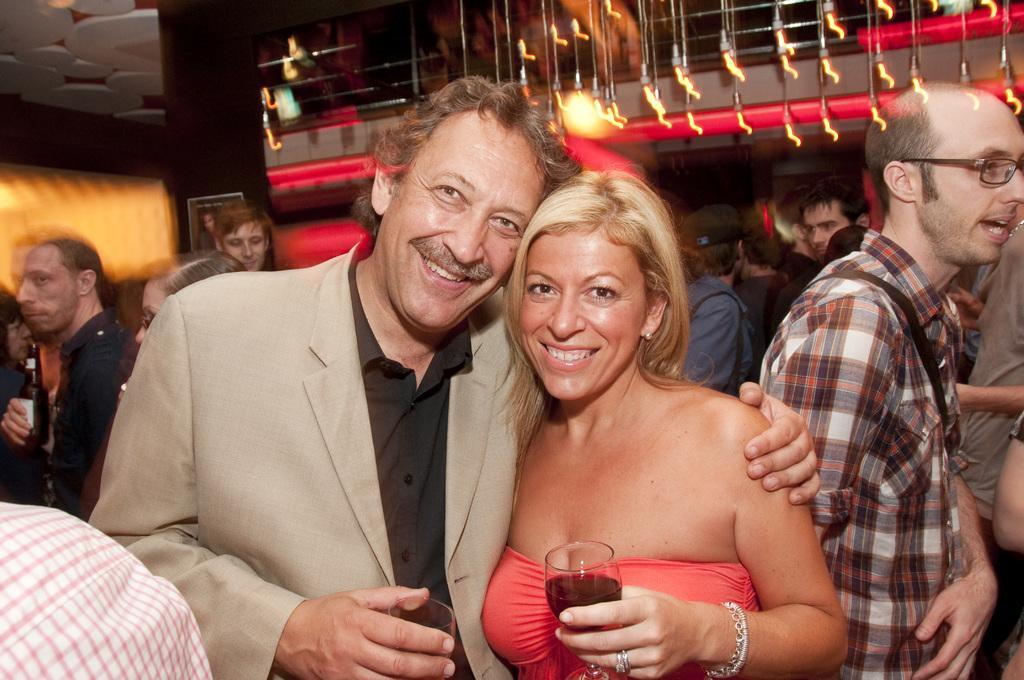In one or two sentences, can you explain what this image depicts? In front of the picture, we see the man and the women are standing. Both of them are holding the glasses in their hands. They are smiling and they are posing for the photo. Behind them, we see many people are standing. At the top, we see some decorative items and the ceiling. This picture might be clicked in the bar. 